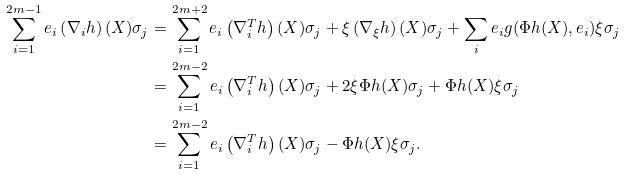Convert formula to latex. <formula><loc_0><loc_0><loc_500><loc_500>\sum _ { i = 1 } ^ { 2 m - 1 } e _ { i } \left ( \nabla _ { i } h \right ) ( X ) \sigma _ { j } & = \sum _ { i = 1 } ^ { 2 m + 2 } e _ { i } \left ( \nabla ^ { T } _ { i } h \right ) ( X ) \sigma _ { j } + \xi \left ( \nabla _ { \xi } h \right ) ( X ) \sigma _ { j } + \sum _ { i } e _ { i } g ( \Phi h ( X ) , e _ { i } ) \xi \sigma _ { j } \\ & = \sum _ { i = 1 } ^ { 2 m - 2 } e _ { i } \left ( \nabla ^ { T } _ { i } h \right ) ( X ) \sigma _ { j } + 2 \xi \Phi h ( X ) \sigma _ { j } + \Phi h ( X ) \xi \sigma _ { j } \\ & = \sum _ { i = 1 } ^ { 2 m - 2 } e _ { i } \left ( \nabla ^ { T } _ { i } h \right ) ( X ) \sigma _ { j } - \Phi h ( X ) \xi \sigma _ { j } . \\</formula> 